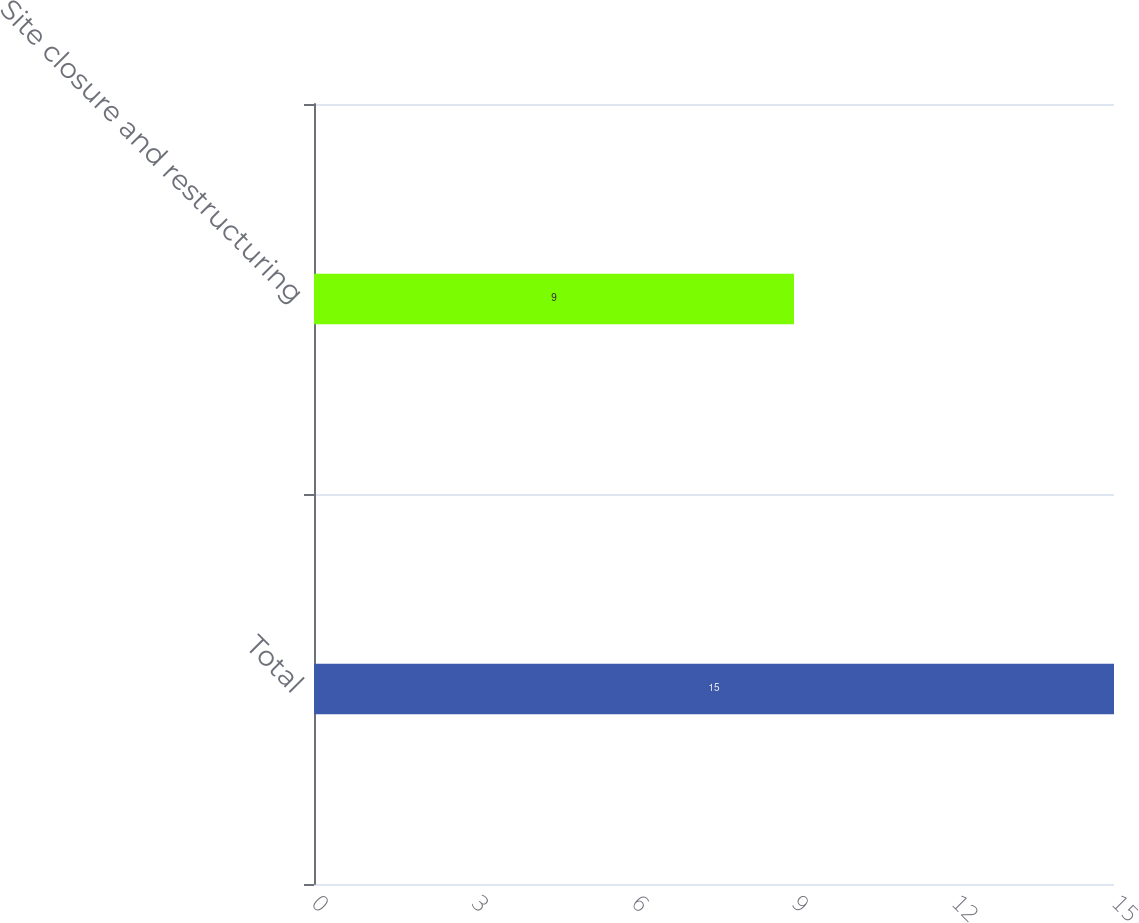Convert chart to OTSL. <chart><loc_0><loc_0><loc_500><loc_500><bar_chart><fcel>Total<fcel>Site closure and restructuring<nl><fcel>15<fcel>9<nl></chart> 